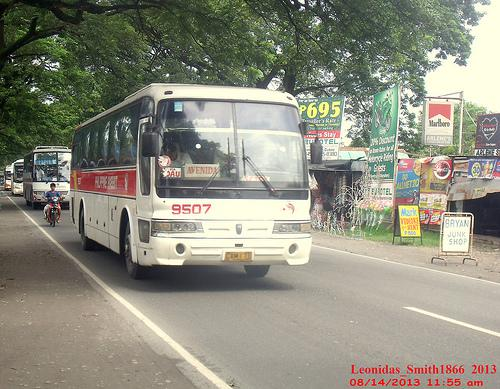Question: why is it so bright?
Choices:
A. Cloudy.
B. Rainy.
C. Sunny.
D. Dim.
Answer with the letter. Answer: C Question: how many buses are there?
Choices:
A. Four.
B. Eight.
C. Six.
D. Five.
Answer with the letter. Answer: A Question: what says Marlboro?
Choices:
A. The cigarette package.
B. The back pack.
C. The sign.
D. The duffle bag.
Answer with the letter. Answer: C Question: what is behind the bus?
Choices:
A. A motorcycle.
B. A blue car.
C. A bike.
D. A horse.
Answer with the letter. Answer: C 